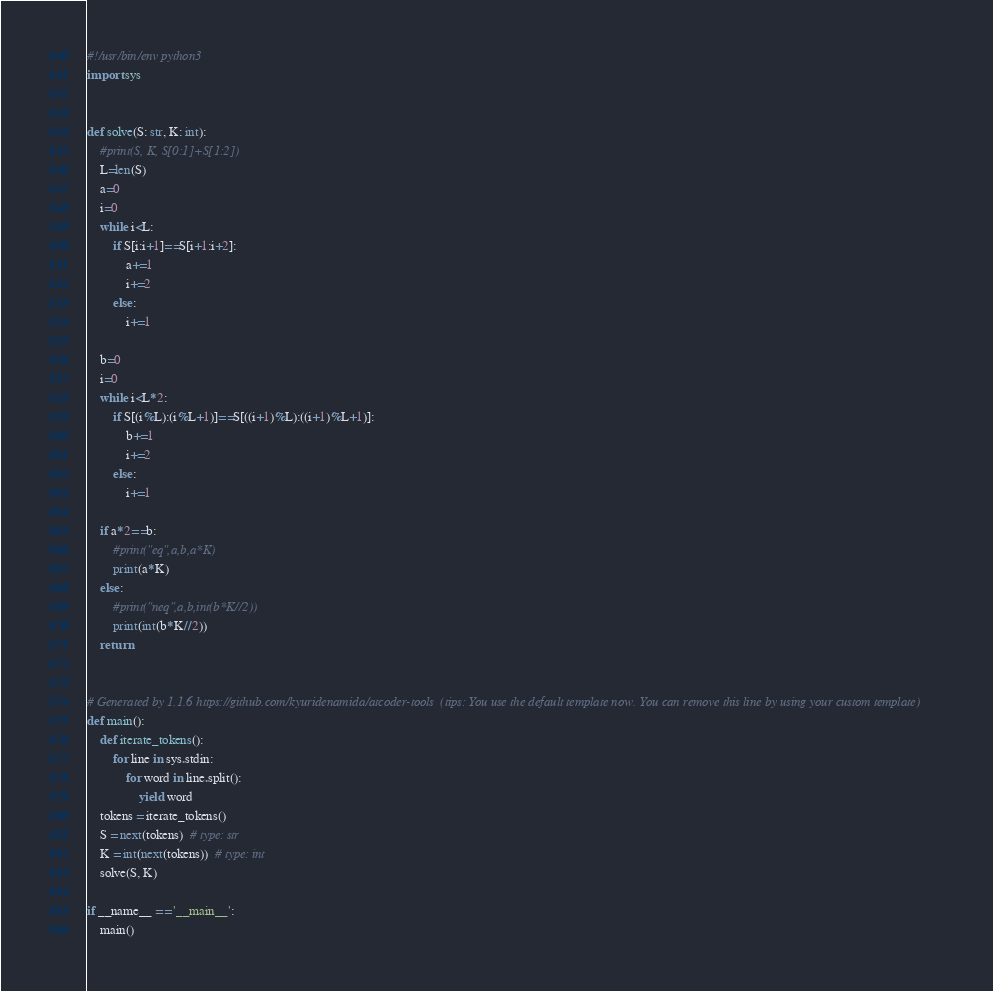<code> <loc_0><loc_0><loc_500><loc_500><_Python_>#!/usr/bin/env python3
import sys


def solve(S: str, K: int):
    #print(S, K, S[0:1]+S[1:2])
    L=len(S)
    a=0
    i=0
    while i<L:
        if S[i:i+1]==S[i+1:i+2]:
            a+=1
            i+=2
        else:
            i+=1

    b=0
    i=0
    while i<L*2:
        if S[(i%L):(i%L+1)]==S[((i+1)%L):((i+1)%L+1)]:
            b+=1
            i+=2
        else:
            i+=1

    if a*2==b:
        #print("eq",a,b,a*K)
        print(a*K)
    else:
        #print("neq",a,b,int(b*K//2))
        print(int(b*K//2))
    return


# Generated by 1.1.6 https://github.com/kyuridenamida/atcoder-tools  (tips: You use the default template now. You can remove this line by using your custom template)
def main():
    def iterate_tokens():
        for line in sys.stdin:
            for word in line.split():
                yield word
    tokens = iterate_tokens()
    S = next(tokens)  # type: str
    K = int(next(tokens))  # type: int
    solve(S, K)

if __name__ == '__main__':
    main()</code> 